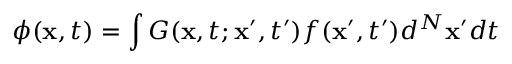Convert formula to latex. <formula><loc_0><loc_0><loc_500><loc_500>\phi ( x , t ) = \int G ( x , t ; x ^ { \prime } , t ^ { \prime } ) f ( x ^ { \prime } , t ^ { \prime } ) d ^ { N } x ^ { \prime } d t</formula> 